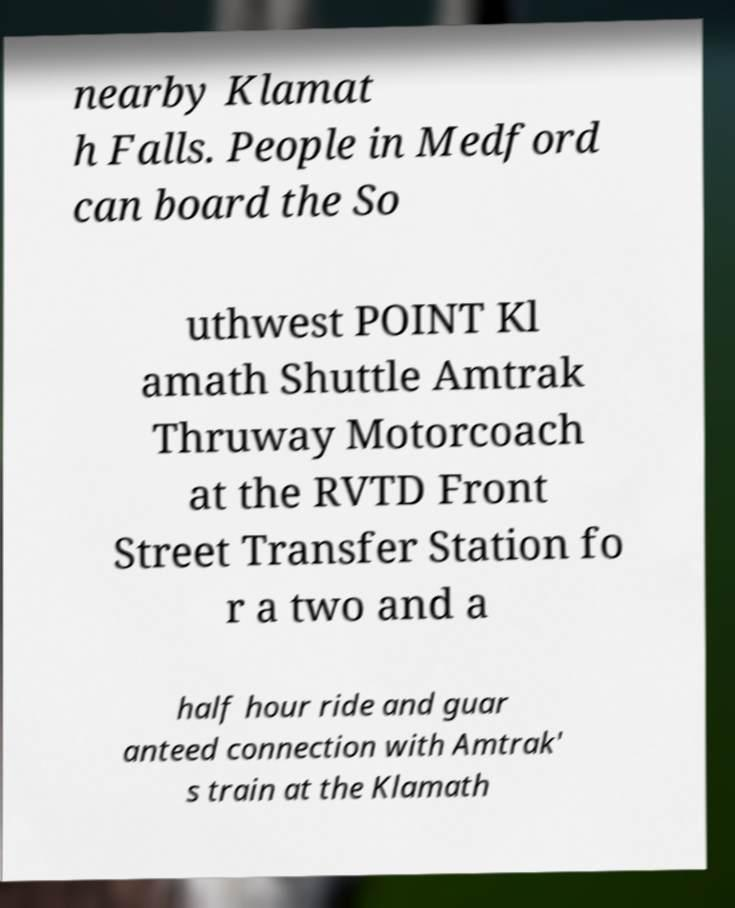For documentation purposes, I need the text within this image transcribed. Could you provide that? nearby Klamat h Falls. People in Medford can board the So uthwest POINT Kl amath Shuttle Amtrak Thruway Motorcoach at the RVTD Front Street Transfer Station fo r a two and a half hour ride and guar anteed connection with Amtrak' s train at the Klamath 